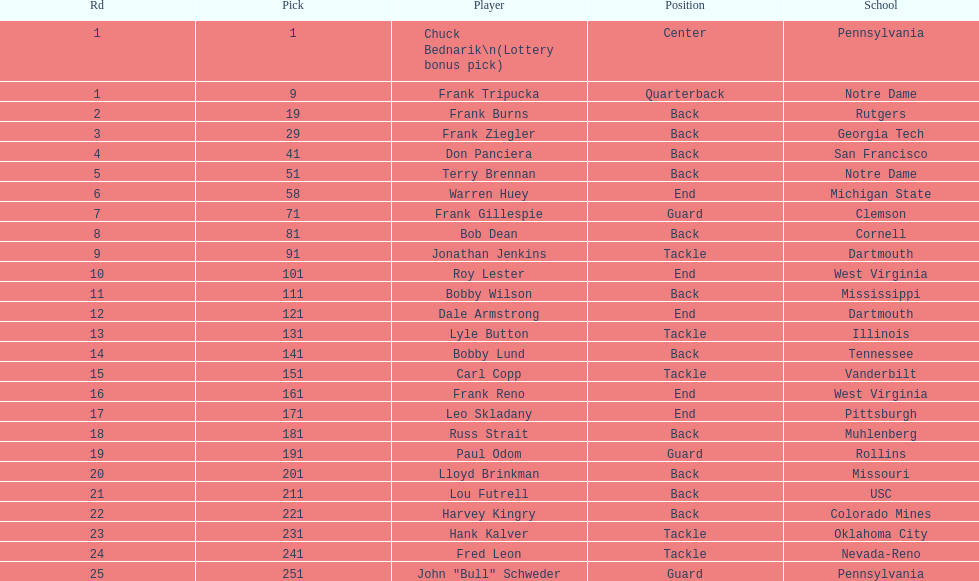Highest rd number? 25. 